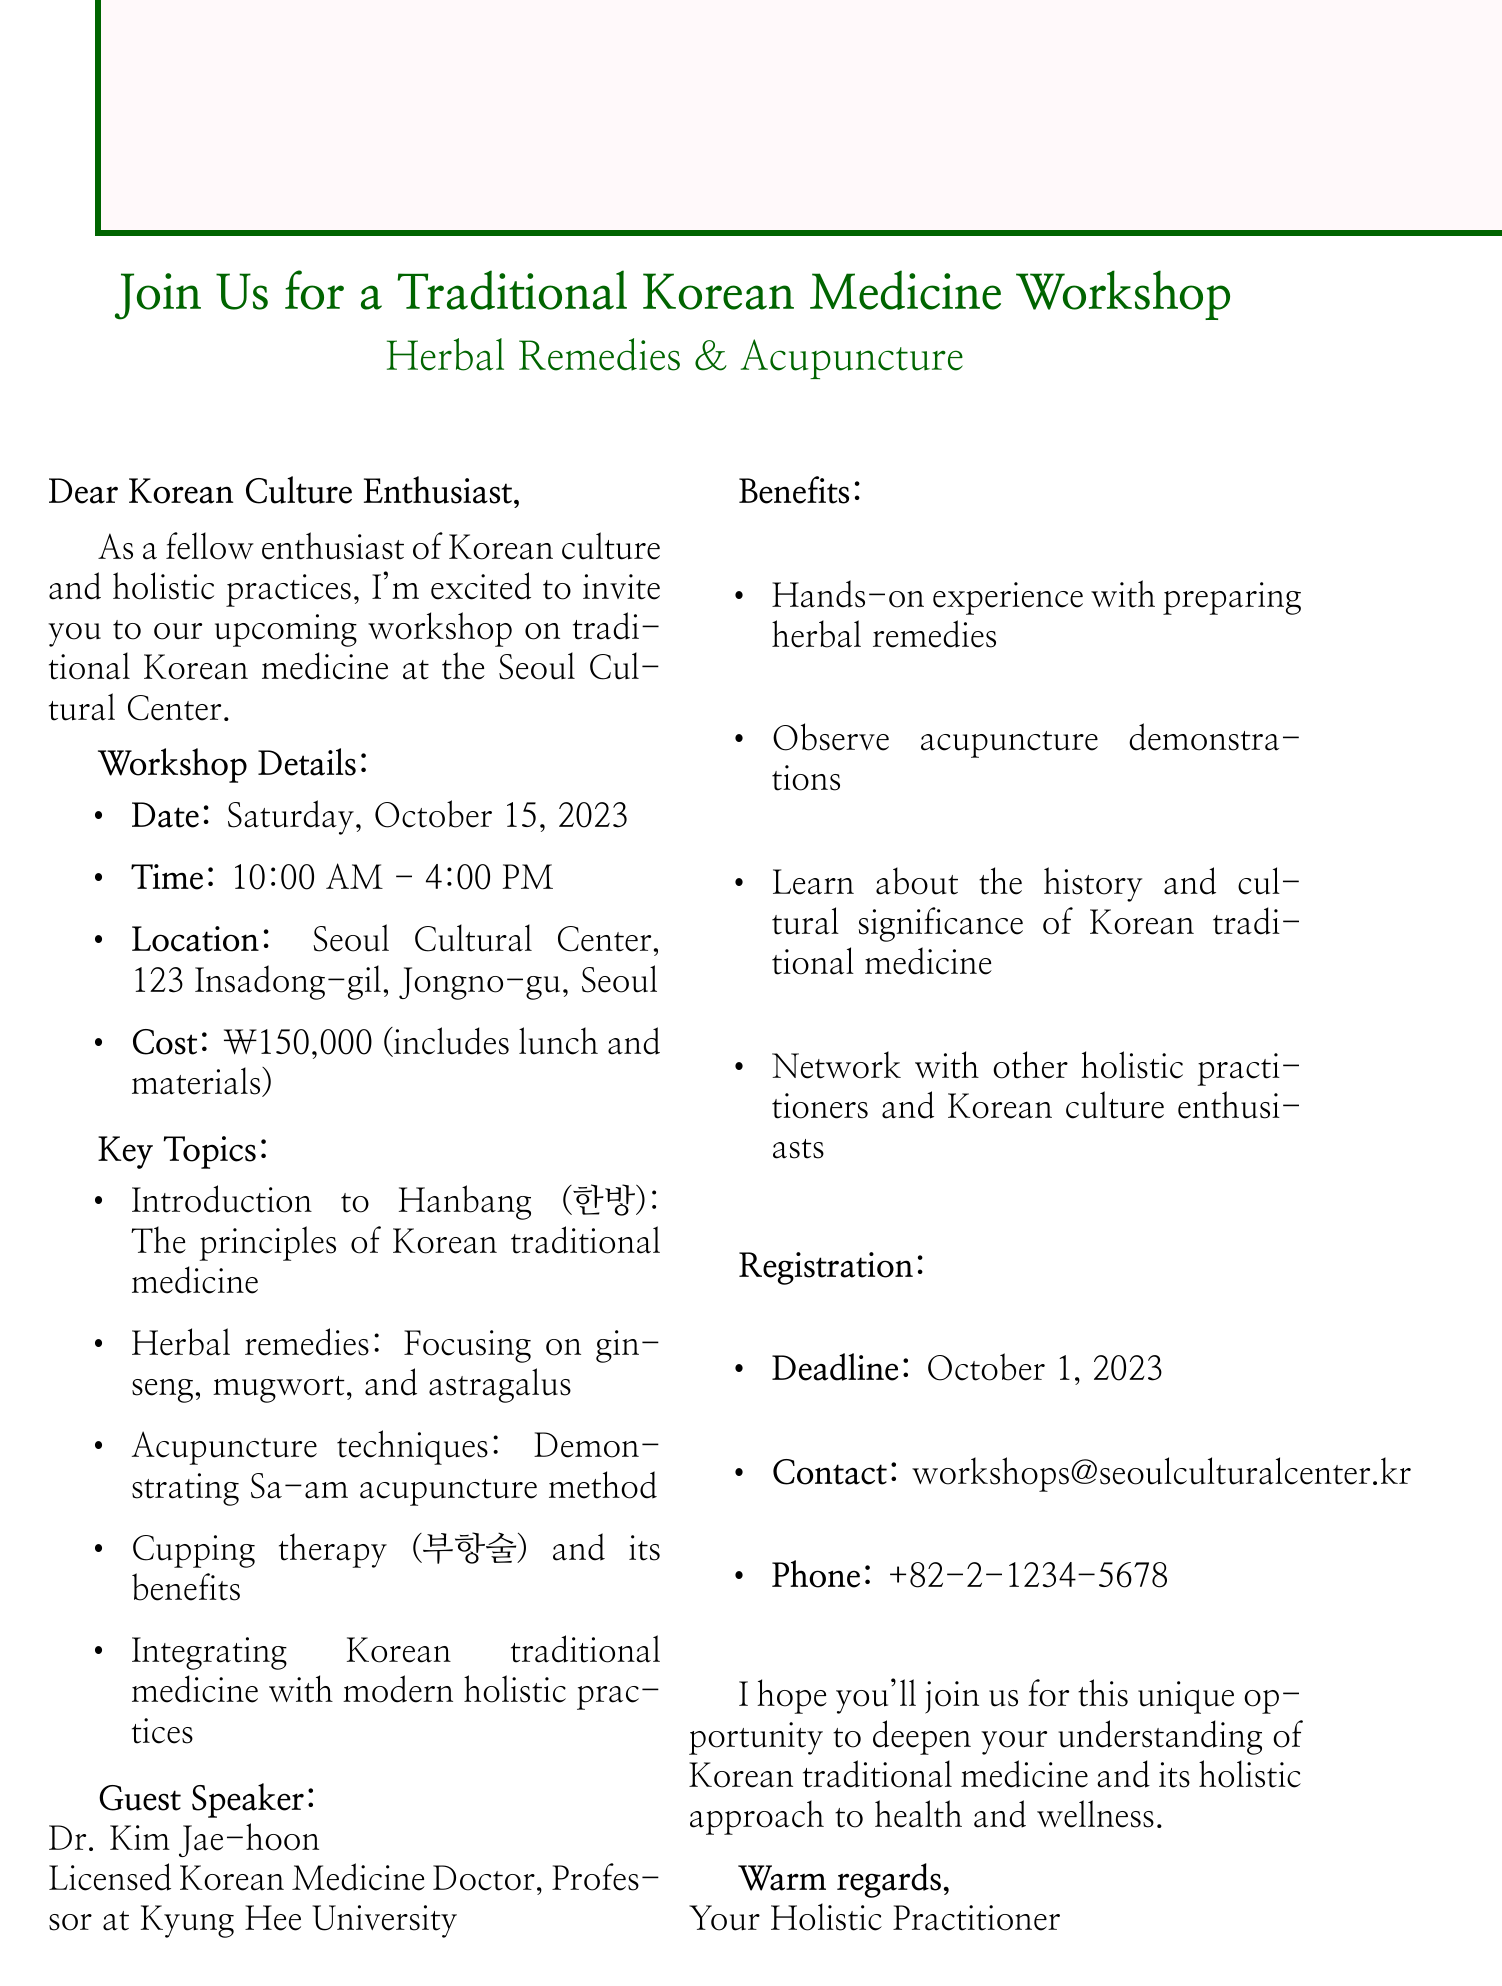What is the date of the workshop? The date of the workshop is specifically mentioned in the document.
Answer: Saturday, October 15, 2023 Who is the guest speaker? The guest speaker's name is provided within the email along with their credentials.
Answer: Dr. Kim Jae-hoon What is the contact email for registration? The email for registration is clearly stated in the registration section of the document.
Answer: workshops@seoulculturalcenter.kr What is the cost of attending the workshop? The document mentions the registration cost for the workshop.
Answer: ₩150,000 What are two key topics covered in the workshop? The workshop features a list of key topics, so two can be easily extracted from that section.
Answer: Introduction to Hanbang and Herbal remedies What benefits are mentioned for attendees? The document lists benefits, summarizing experiences available to attendees, including hands-on activities.
Answer: Hands-on experience with preparing herbal remedies When is the registration deadline? The registration deadline is explicitly provided in the email, making it easy to find.
Answer: October 1, 2023 How long will the workshop last? The duration of the workshop is indicated by the start and end times mentioned.
Answer: 6 hours What location hosts the workshop? The precise location is mentioned in the workshop details section of the document.
Answer: Seoul Cultural Center, 123 Insadong-gil, Jongno-gu, Seoul 